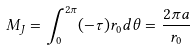Convert formula to latex. <formula><loc_0><loc_0><loc_500><loc_500>M _ { J } = \int ^ { 2 \pi } _ { 0 } ( - \tau ) r _ { 0 } d \theta = \frac { 2 \pi a } { r _ { 0 } }</formula> 